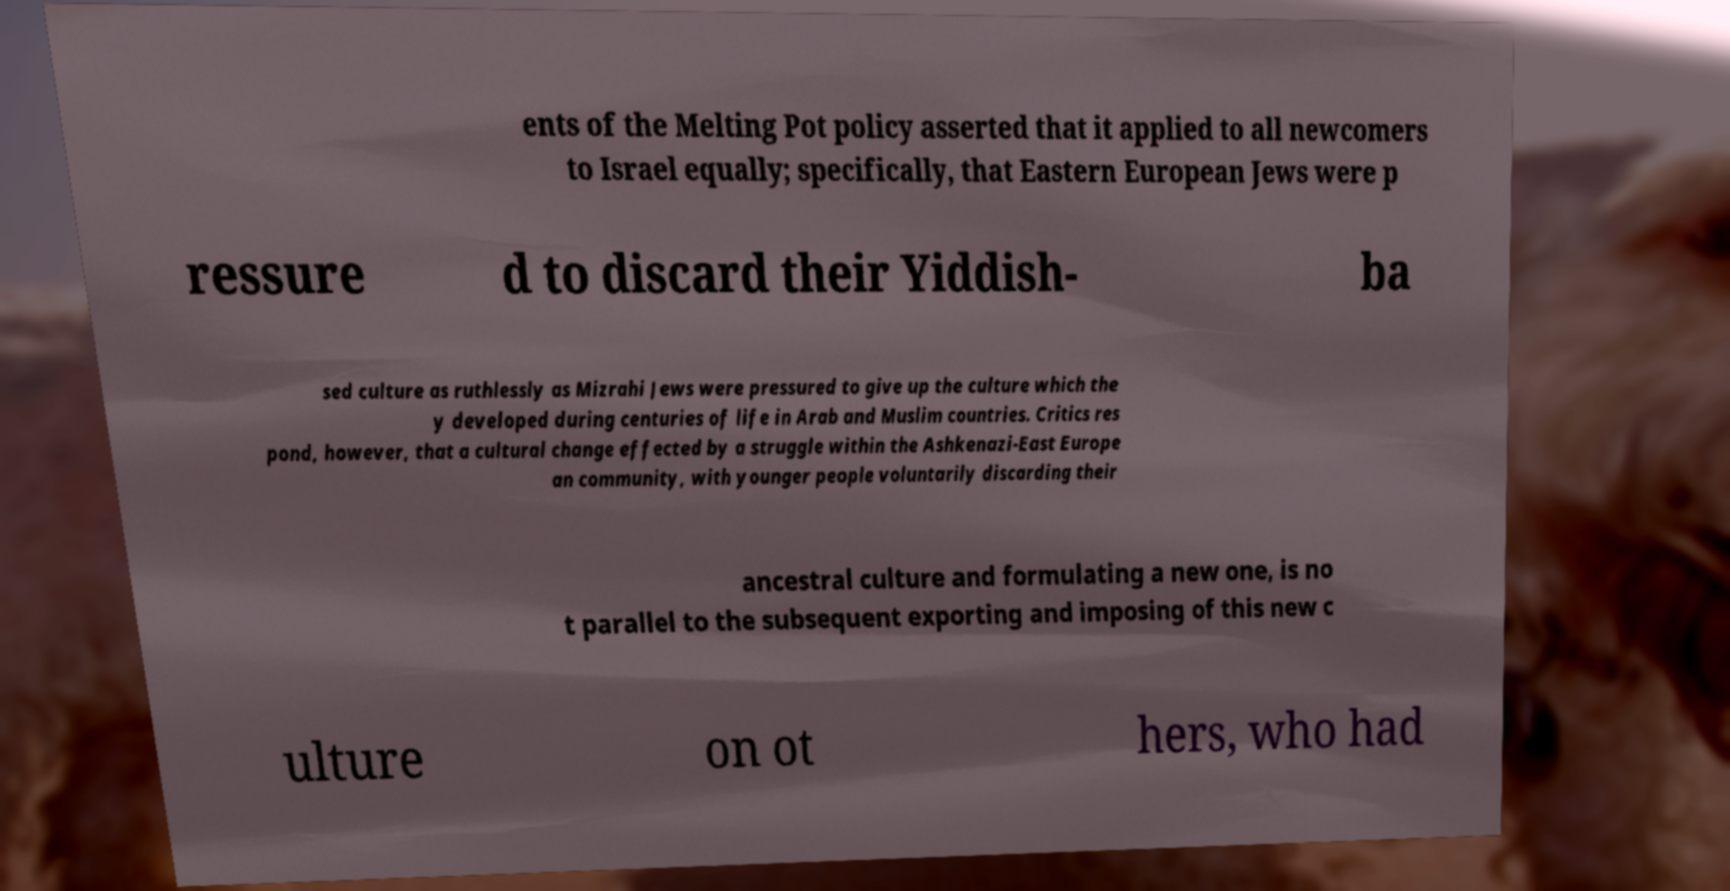I need the written content from this picture converted into text. Can you do that? ents of the Melting Pot policy asserted that it applied to all newcomers to Israel equally; specifically, that Eastern European Jews were p ressure d to discard their Yiddish- ba sed culture as ruthlessly as Mizrahi Jews were pressured to give up the culture which the y developed during centuries of life in Arab and Muslim countries. Critics res pond, however, that a cultural change effected by a struggle within the Ashkenazi-East Europe an community, with younger people voluntarily discarding their ancestral culture and formulating a new one, is no t parallel to the subsequent exporting and imposing of this new c ulture on ot hers, who had 